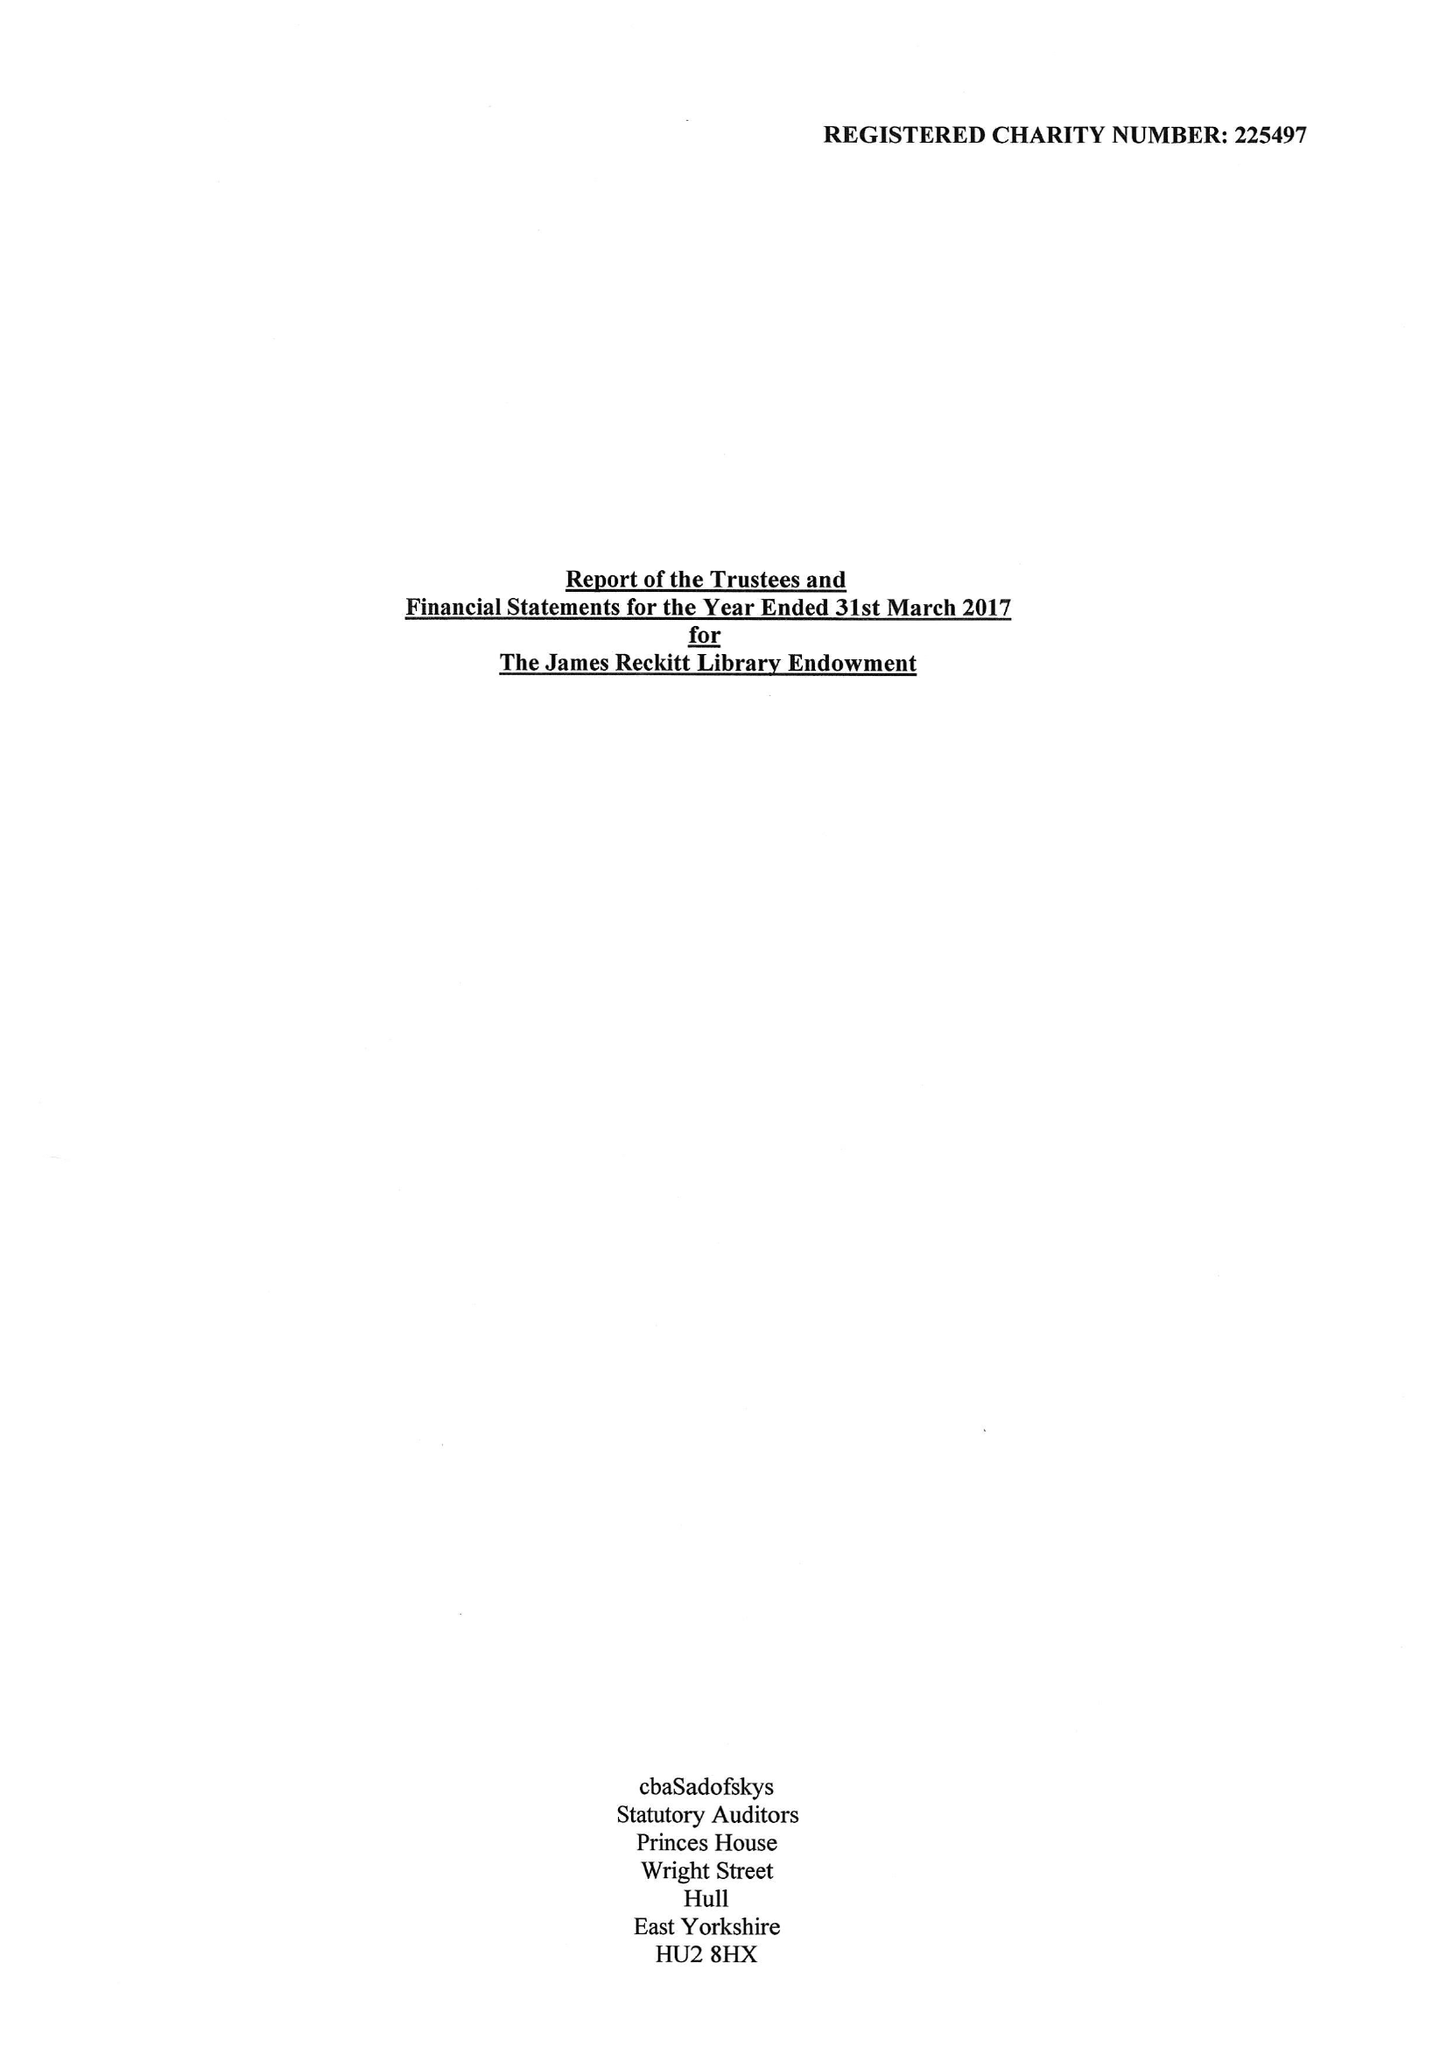What is the value for the report_date?
Answer the question using a single word or phrase. 2017-03-31 